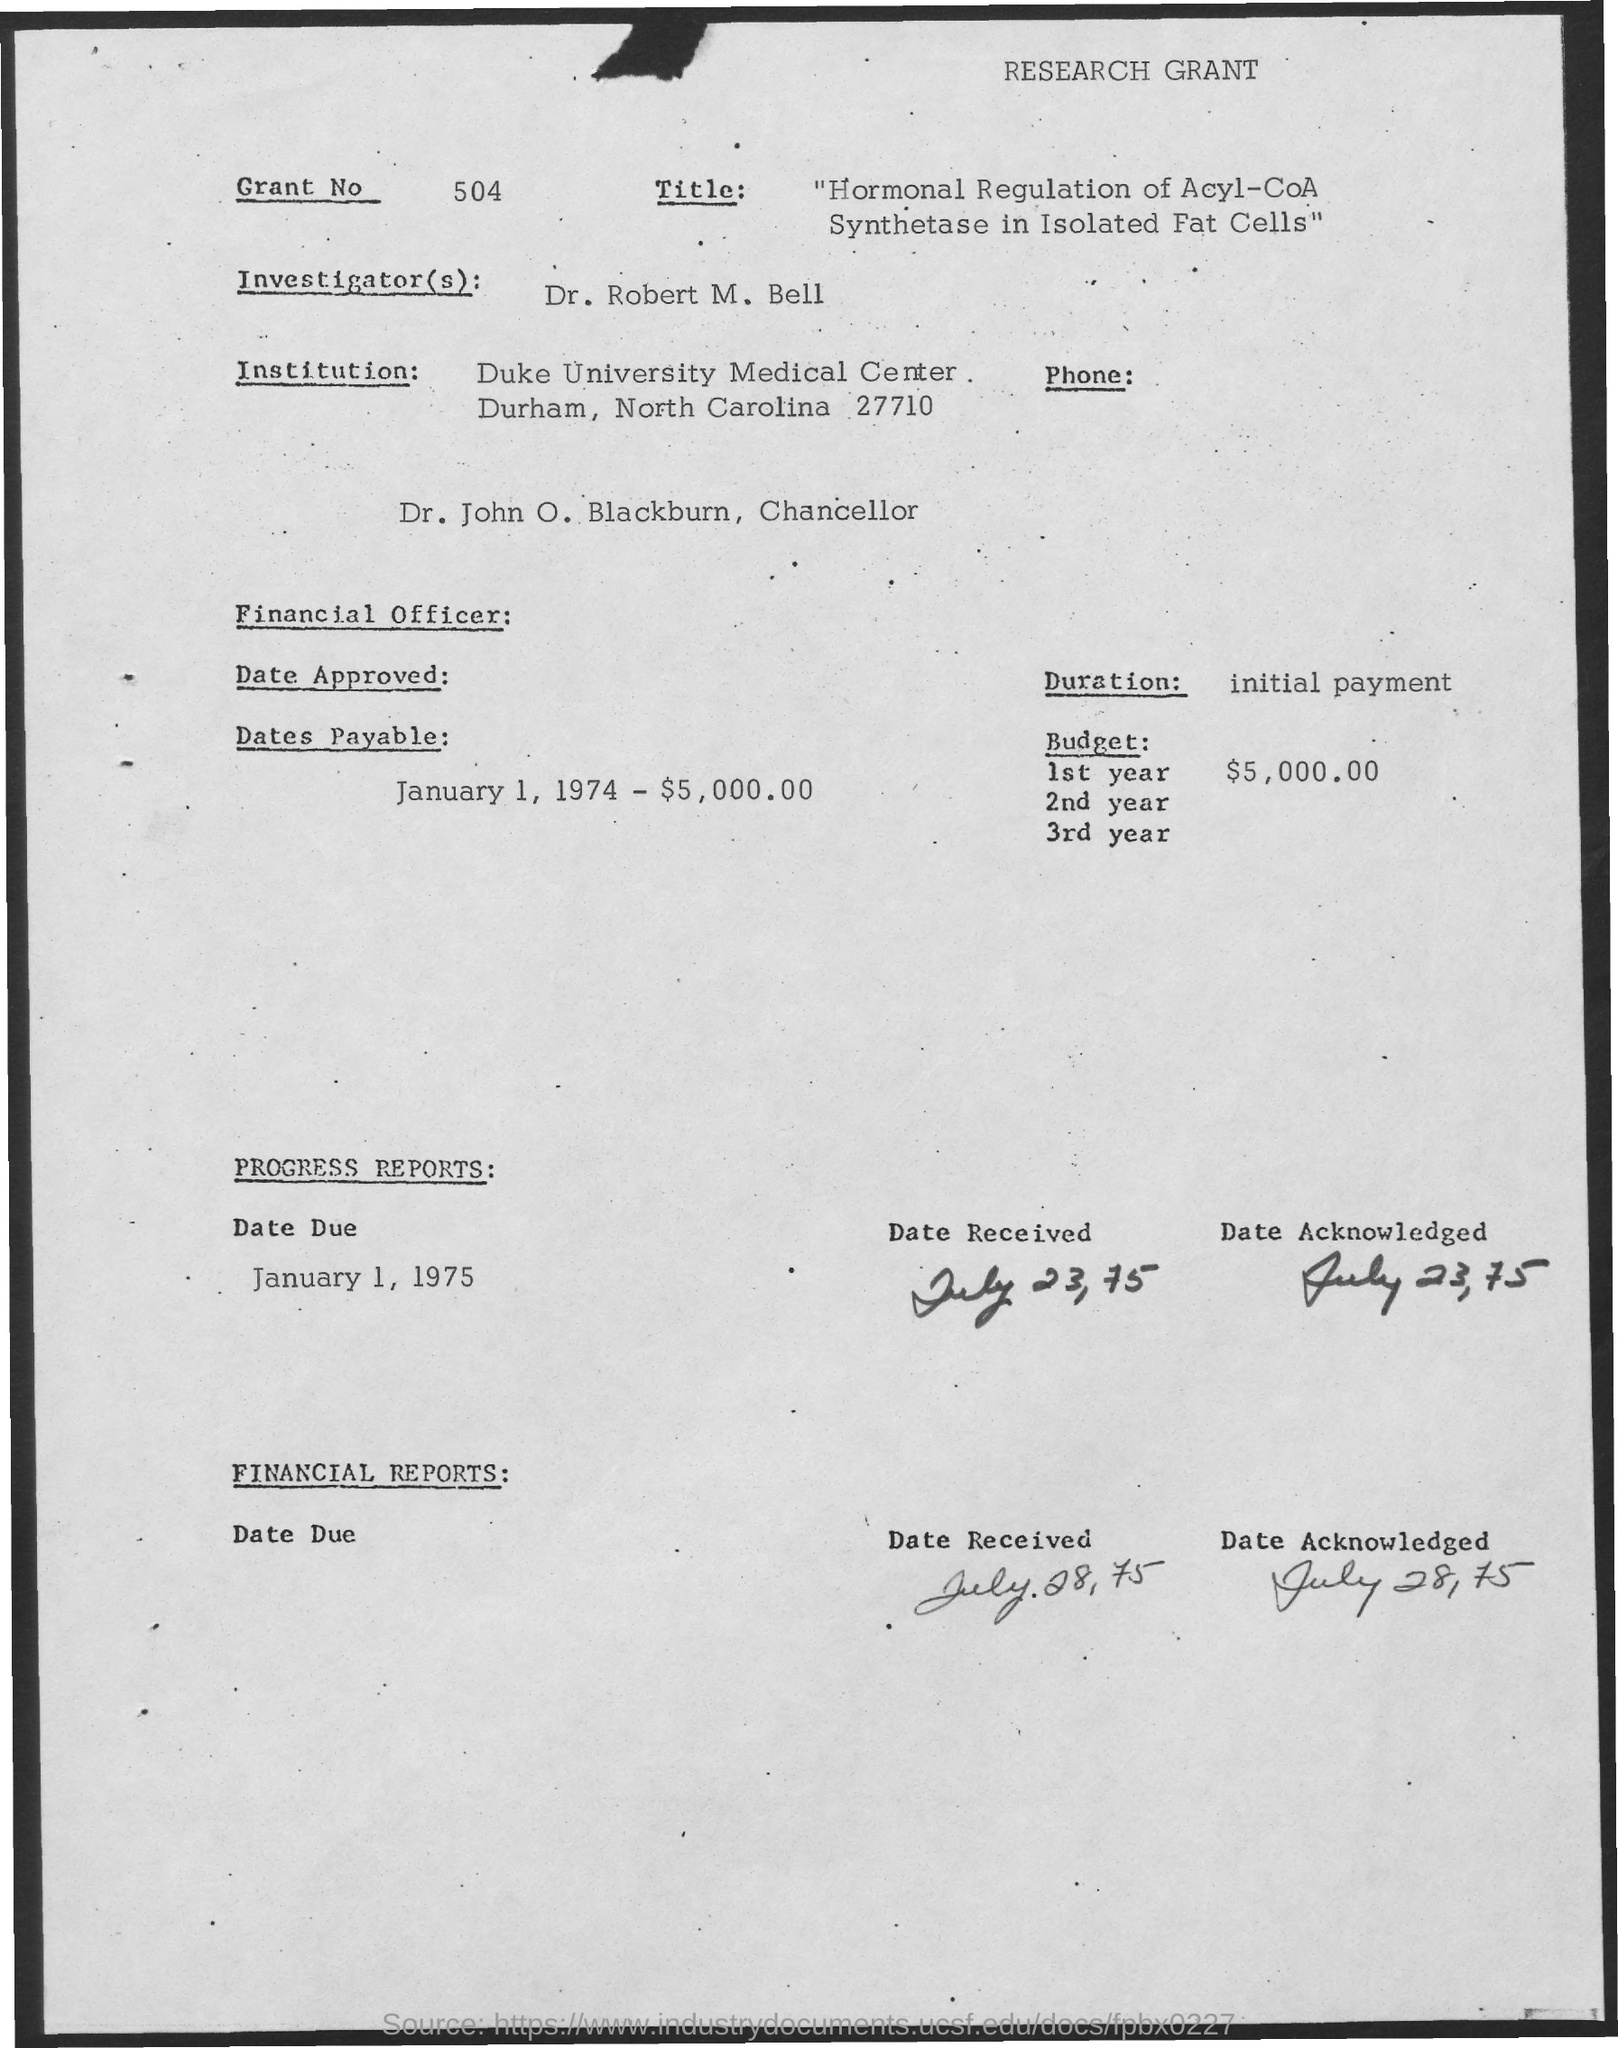What is the Grant No. mentioned in this document?
Your answer should be very brief. 504. Who is the Investigator as per the document?
Ensure brevity in your answer.  Dr. Robert M. Bell. Who is Dr. John O. Blackburn?
Your response must be concise. Chancellor. What is the due date of progress reports?
Make the answer very short. January 1, 1975. What is the received date of financial reports?
Offer a terse response. July 28, 75. What is the budget estimate for 1st year of research grant?
Make the answer very short. $5,000.00. 